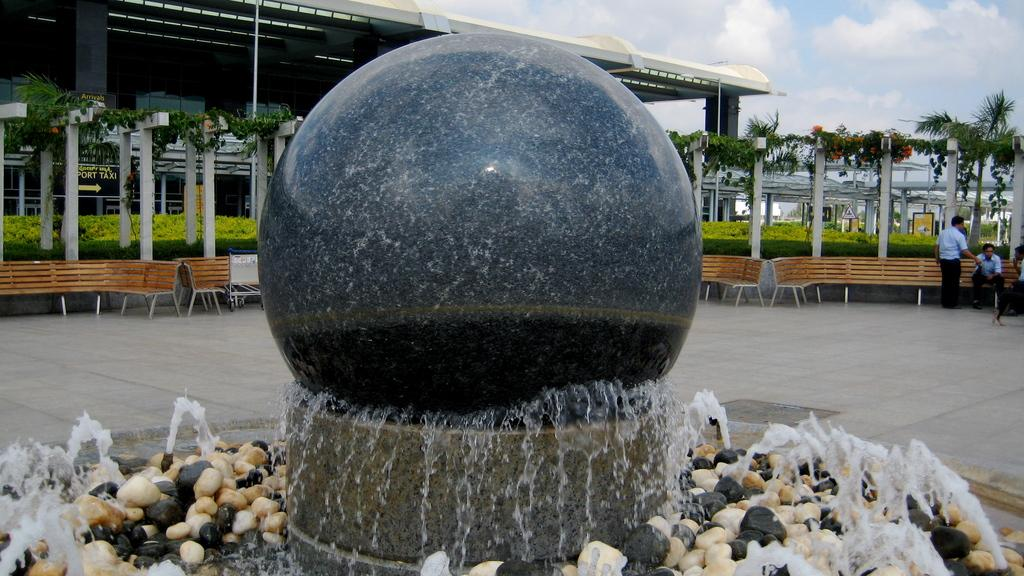What is the condition of the sky in the image? The sky is cloudy in the image. What can be seen in the background of the image? There is a building, a tree, plants, and benches in the background. How many people are in the image? There are two people in the image. What is the water feature in the image? There is a water fountain with rocks in the image. What type of line is being used by the people in the image? There is no line present in the image; the people are not waiting or standing in a queue. Can you see an apple tree in the image? There is no apple tree or any fruit tree present in the image. 